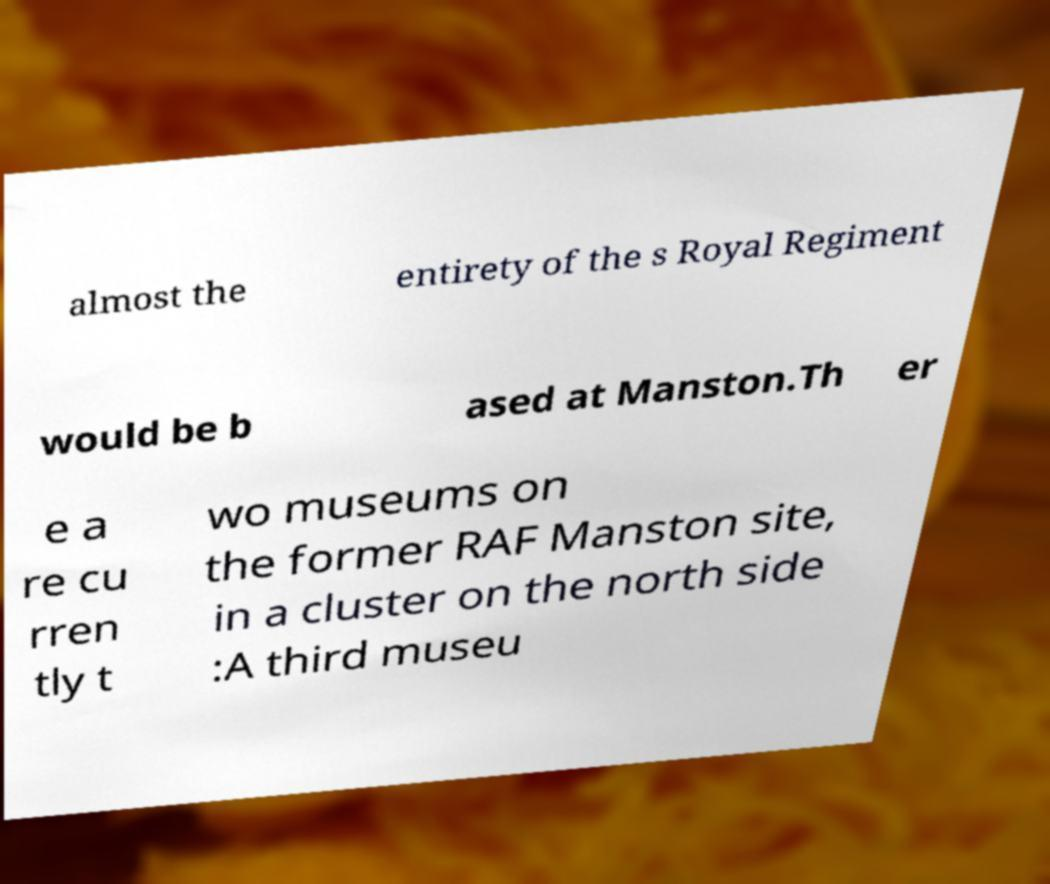There's text embedded in this image that I need extracted. Can you transcribe it verbatim? almost the entirety of the s Royal Regiment would be b ased at Manston.Th er e a re cu rren tly t wo museums on the former RAF Manston site, in a cluster on the north side :A third museu 